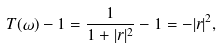Convert formula to latex. <formula><loc_0><loc_0><loc_500><loc_500>T ( \omega ) - 1 = \frac { 1 } { 1 + | r | ^ { 2 } } - 1 = - | r | ^ { 2 } ,</formula> 